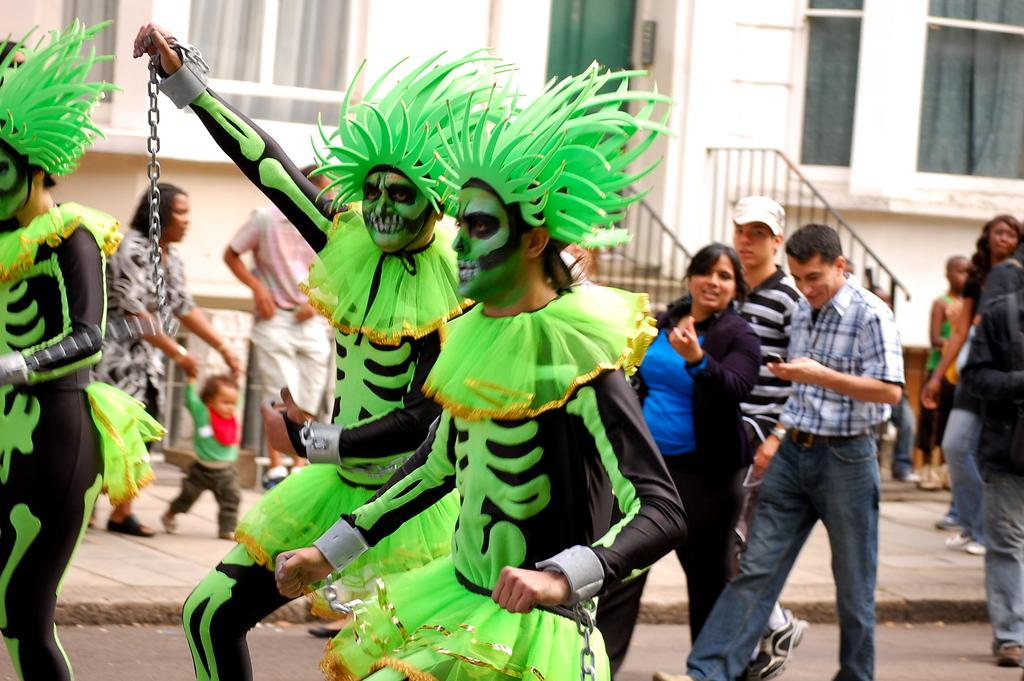Who or what can be seen in the image? There are people in the image. What is visible in the background of the image? There is a building in the background of the image. What feature can be observed in the image that might be related to safety or structure? There are railings in the image. Can you see any clovers growing near the people in the image? There are no clovers visible in the image. Is there a camp set up in the background of the image? There is no camp visible in the image; only a building can be seen in the background. 